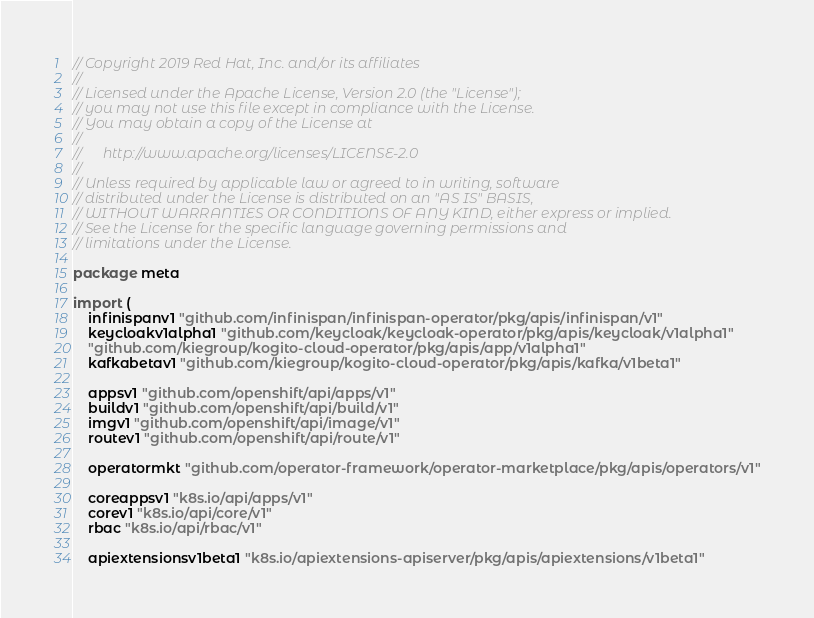<code> <loc_0><loc_0><loc_500><loc_500><_Go_>// Copyright 2019 Red Hat, Inc. and/or its affiliates
//
// Licensed under the Apache License, Version 2.0 (the "License");
// you may not use this file except in compliance with the License.
// You may obtain a copy of the License at
//
//      http://www.apache.org/licenses/LICENSE-2.0
//
// Unless required by applicable law or agreed to in writing, software
// distributed under the License is distributed on an "AS IS" BASIS,
// WITHOUT WARRANTIES OR CONDITIONS OF ANY KIND, either express or implied.
// See the License for the specific language governing permissions and
// limitations under the License.

package meta

import (
	infinispanv1 "github.com/infinispan/infinispan-operator/pkg/apis/infinispan/v1"
	keycloakv1alpha1 "github.com/keycloak/keycloak-operator/pkg/apis/keycloak/v1alpha1"
	"github.com/kiegroup/kogito-cloud-operator/pkg/apis/app/v1alpha1"
	kafkabetav1 "github.com/kiegroup/kogito-cloud-operator/pkg/apis/kafka/v1beta1"

	appsv1 "github.com/openshift/api/apps/v1"
	buildv1 "github.com/openshift/api/build/v1"
	imgv1 "github.com/openshift/api/image/v1"
	routev1 "github.com/openshift/api/route/v1"

	operatormkt "github.com/operator-framework/operator-marketplace/pkg/apis/operators/v1"

	coreappsv1 "k8s.io/api/apps/v1"
	corev1 "k8s.io/api/core/v1"
	rbac "k8s.io/api/rbac/v1"

	apiextensionsv1beta1 "k8s.io/apiextensions-apiserver/pkg/apis/apiextensions/v1beta1"
</code> 